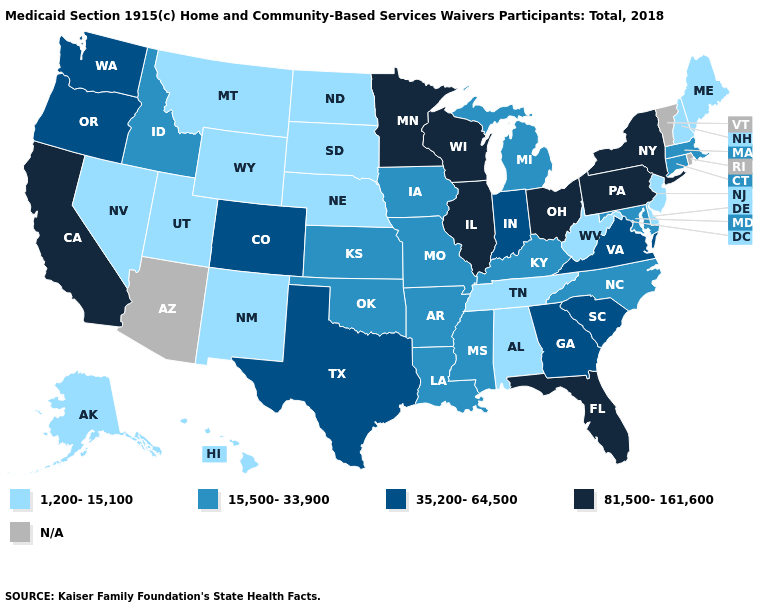Name the states that have a value in the range 1,200-15,100?
Concise answer only. Alabama, Alaska, Delaware, Hawaii, Maine, Montana, Nebraska, Nevada, New Hampshire, New Jersey, New Mexico, North Dakota, South Dakota, Tennessee, Utah, West Virginia, Wyoming. What is the value of New Hampshire?
Short answer required. 1,200-15,100. What is the highest value in the USA?
Give a very brief answer. 81,500-161,600. Name the states that have a value in the range 1,200-15,100?
Short answer required. Alabama, Alaska, Delaware, Hawaii, Maine, Montana, Nebraska, Nevada, New Hampshire, New Jersey, New Mexico, North Dakota, South Dakota, Tennessee, Utah, West Virginia, Wyoming. Which states hav the highest value in the West?
Write a very short answer. California. Name the states that have a value in the range 15,500-33,900?
Be succinct. Arkansas, Connecticut, Idaho, Iowa, Kansas, Kentucky, Louisiana, Maryland, Massachusetts, Michigan, Mississippi, Missouri, North Carolina, Oklahoma. Name the states that have a value in the range 1,200-15,100?
Answer briefly. Alabama, Alaska, Delaware, Hawaii, Maine, Montana, Nebraska, Nevada, New Hampshire, New Jersey, New Mexico, North Dakota, South Dakota, Tennessee, Utah, West Virginia, Wyoming. Name the states that have a value in the range N/A?
Give a very brief answer. Arizona, Rhode Island, Vermont. Does the map have missing data?
Short answer required. Yes. Does Minnesota have the lowest value in the USA?
Give a very brief answer. No. What is the value of New York?
Short answer required. 81,500-161,600. Does North Dakota have the highest value in the USA?
Quick response, please. No. Does Connecticut have the lowest value in the USA?
Answer briefly. No. What is the lowest value in the South?
Keep it brief. 1,200-15,100. Does the first symbol in the legend represent the smallest category?
Answer briefly. Yes. 